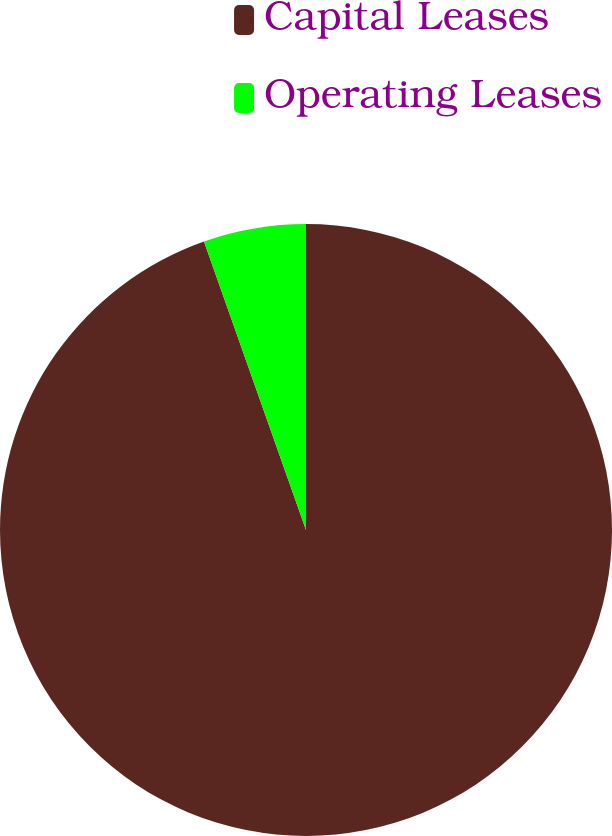<chart> <loc_0><loc_0><loc_500><loc_500><pie_chart><fcel>Capital Leases<fcel>Operating Leases<nl><fcel>94.59%<fcel>5.41%<nl></chart> 